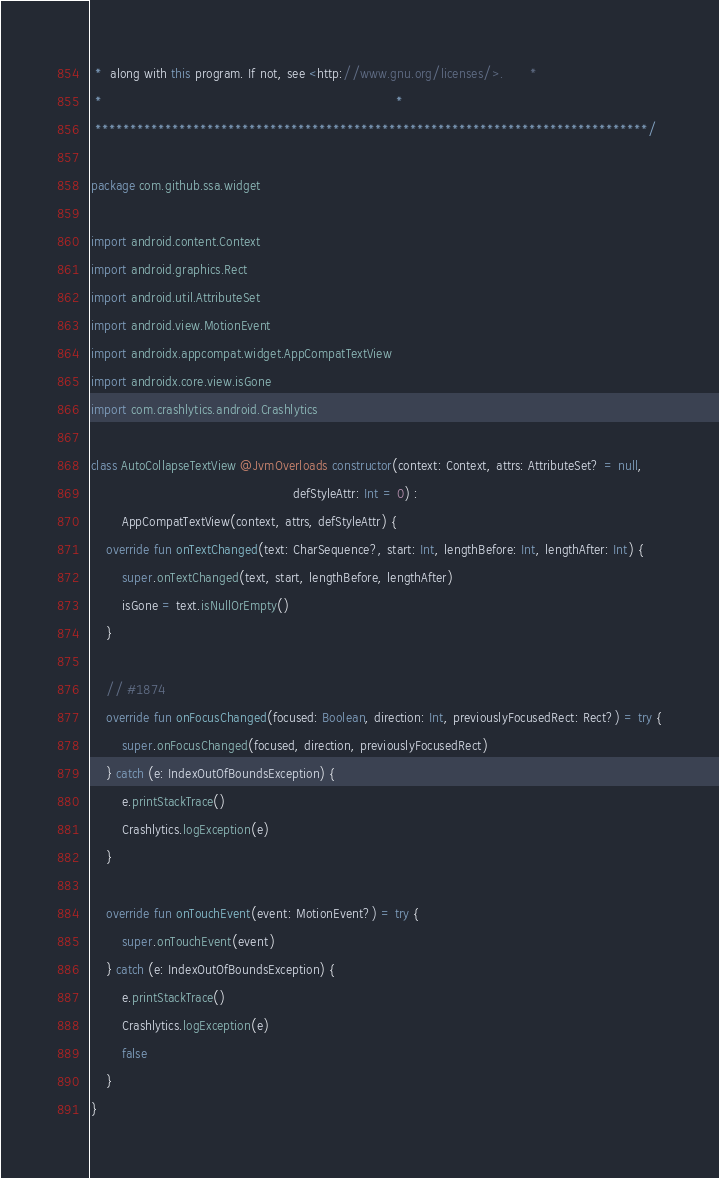<code> <loc_0><loc_0><loc_500><loc_500><_Kotlin_> *  along with this program. If not, see <http://www.gnu.org/licenses/>.       *
 *                                                                             *
 *******************************************************************************/

package com.github.ssa.widget

import android.content.Context
import android.graphics.Rect
import android.util.AttributeSet
import android.view.MotionEvent
import androidx.appcompat.widget.AppCompatTextView
import androidx.core.view.isGone
import com.crashlytics.android.Crashlytics

class AutoCollapseTextView @JvmOverloads constructor(context: Context, attrs: AttributeSet? = null,
                                                     defStyleAttr: Int = 0) :
        AppCompatTextView(context, attrs, defStyleAttr) {
    override fun onTextChanged(text: CharSequence?, start: Int, lengthBefore: Int, lengthAfter: Int) {
        super.onTextChanged(text, start, lengthBefore, lengthAfter)
        isGone = text.isNullOrEmpty()
    }

    // #1874
    override fun onFocusChanged(focused: Boolean, direction: Int, previouslyFocusedRect: Rect?) = try {
        super.onFocusChanged(focused, direction, previouslyFocusedRect)
    } catch (e: IndexOutOfBoundsException) {
        e.printStackTrace()
        Crashlytics.logException(e)
    }

    override fun onTouchEvent(event: MotionEvent?) = try {
        super.onTouchEvent(event)
    } catch (e: IndexOutOfBoundsException) {
        e.printStackTrace()
        Crashlytics.logException(e)
        false
    }
}
</code> 